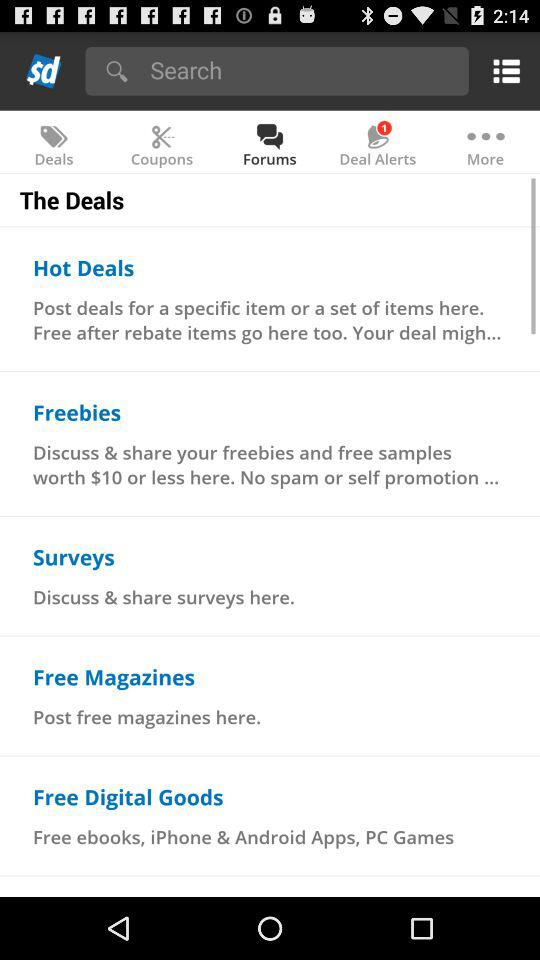Which tab is selected? The selected tab is "Forums". 